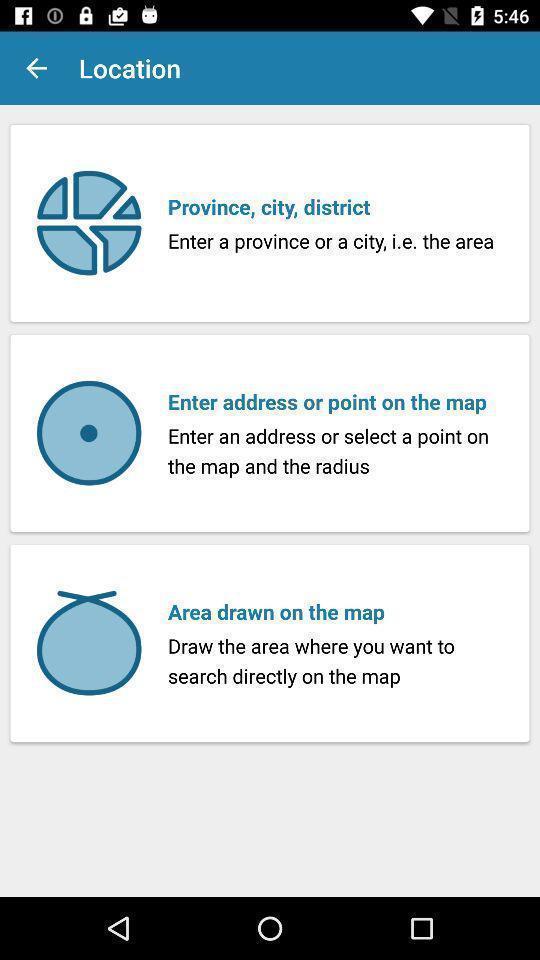What details can you identify in this image? Page of a map application showing different options. 